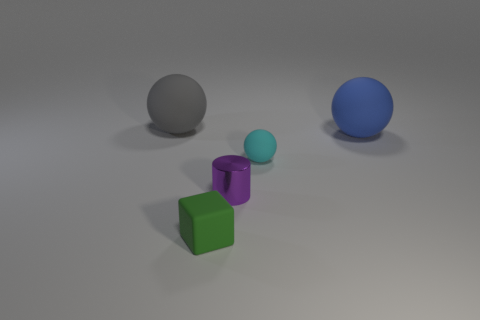Are there fewer small cyan things that are behind the tiny cyan sphere than small green rubber things?
Offer a very short reply. Yes. What number of cyan spheres are the same size as the metallic object?
Keep it short and to the point. 1. Do the object left of the small green block and the rubber thing that is in front of the small cyan rubber object have the same color?
Your answer should be compact. No. How many gray rubber things are right of the small purple metal cylinder?
Keep it short and to the point. 0. Is there a shiny thing of the same shape as the large blue rubber object?
Provide a short and direct response. No. There is a rubber cube that is the same size as the purple cylinder; what is its color?
Give a very brief answer. Green. Are there fewer big gray matte things left of the large gray rubber object than purple things that are to the right of the rubber block?
Provide a succinct answer. Yes. There is a blue matte sphere that is behind the cyan rubber ball; does it have the same size as the purple shiny thing?
Your response must be concise. No. There is a large object on the left side of the small purple cylinder; what is its shape?
Offer a terse response. Sphere. Is the number of cyan matte spheres greater than the number of large balls?
Your response must be concise. No. 